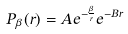<formula> <loc_0><loc_0><loc_500><loc_500>P _ { \beta } ( r ) = A e ^ { - \frac { \beta } { r } } e ^ { - B r }</formula> 